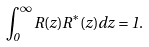Convert formula to latex. <formula><loc_0><loc_0><loc_500><loc_500>\int _ { 0 } ^ { \infty } R ( z ) R ^ { * } ( z ) d z = 1 .</formula> 